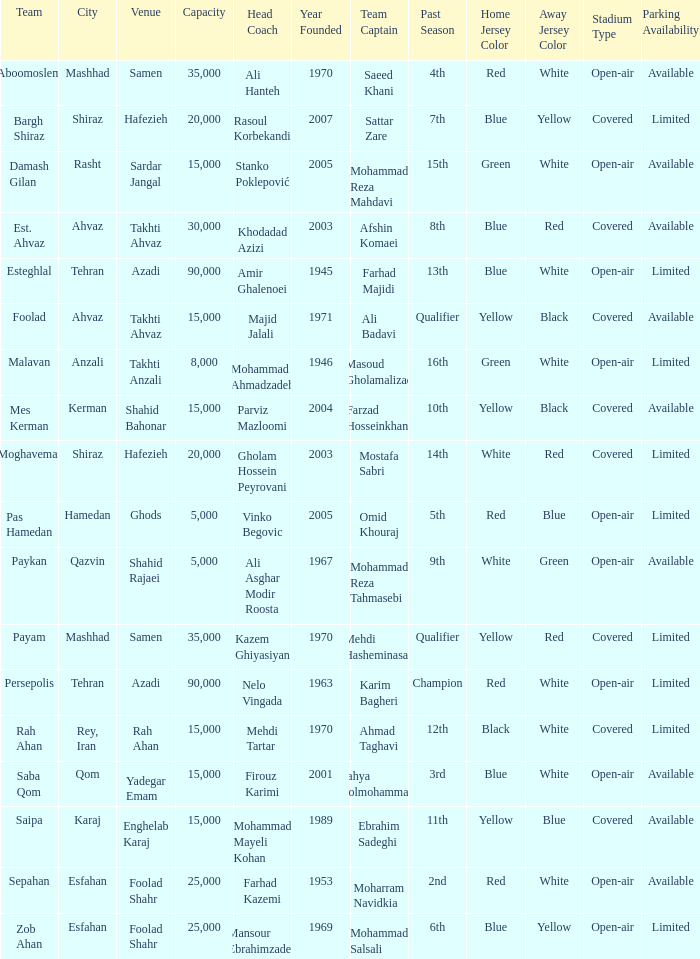What is the Capacity of the Venue of Head Coach Farhad Kazemi? 25000.0. 